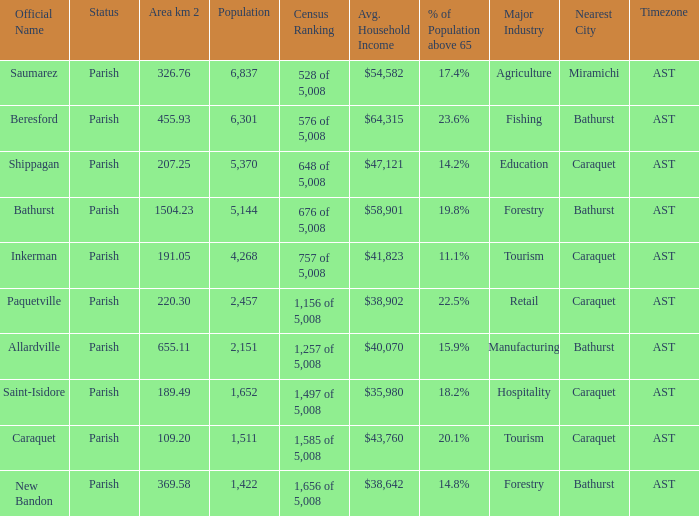What is the Area of the Saint-Isidore Parish with a Population smaller than 4,268? 189.49. 